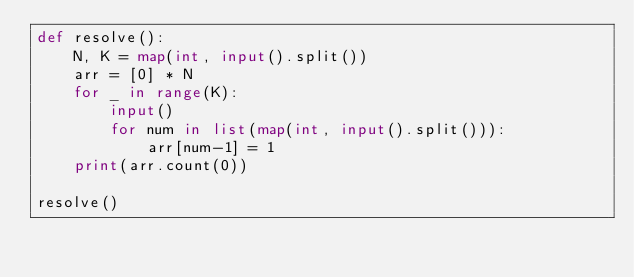<code> <loc_0><loc_0><loc_500><loc_500><_Python_>def resolve():
    N, K = map(int, input().split())
    arr = [0] * N
    for _ in range(K):
        input()
        for num in list(map(int, input().split())):
            arr[num-1] = 1
    print(arr.count(0))

resolve()</code> 